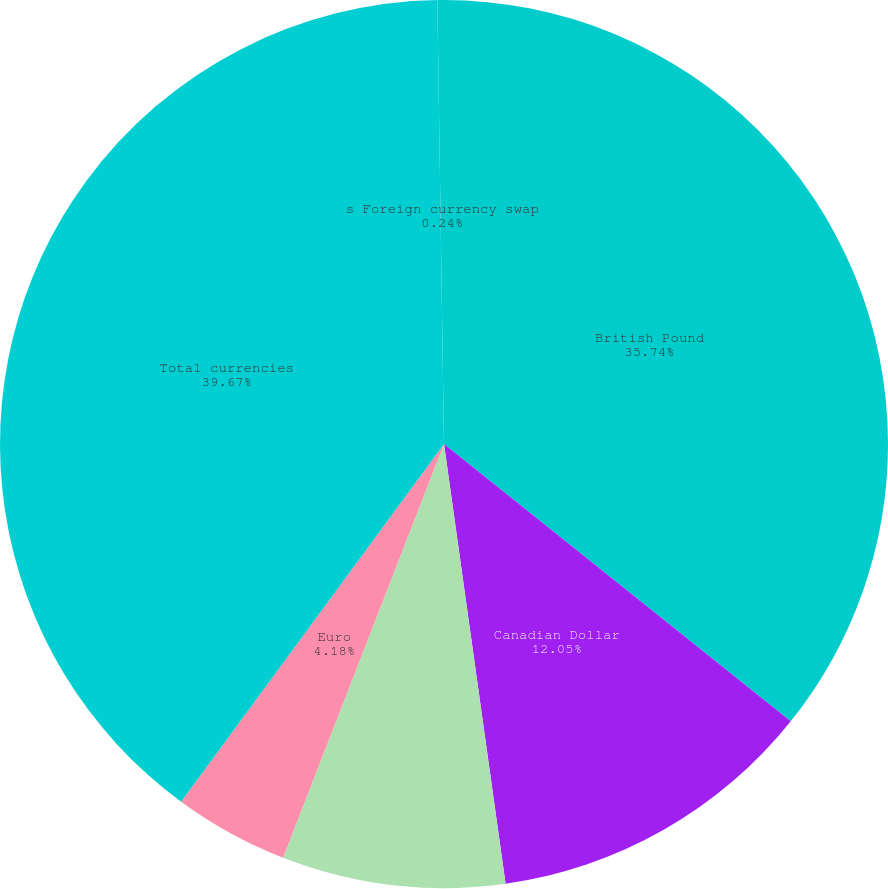<chart> <loc_0><loc_0><loc_500><loc_500><pie_chart><fcel>British Pound<fcel>Canadian Dollar<fcel>New Zealand Dollar<fcel>Euro<fcel>Total currencies<fcel>s Foreign currency swap<nl><fcel>35.74%<fcel>12.05%<fcel>8.12%<fcel>4.18%<fcel>39.68%<fcel>0.24%<nl></chart> 